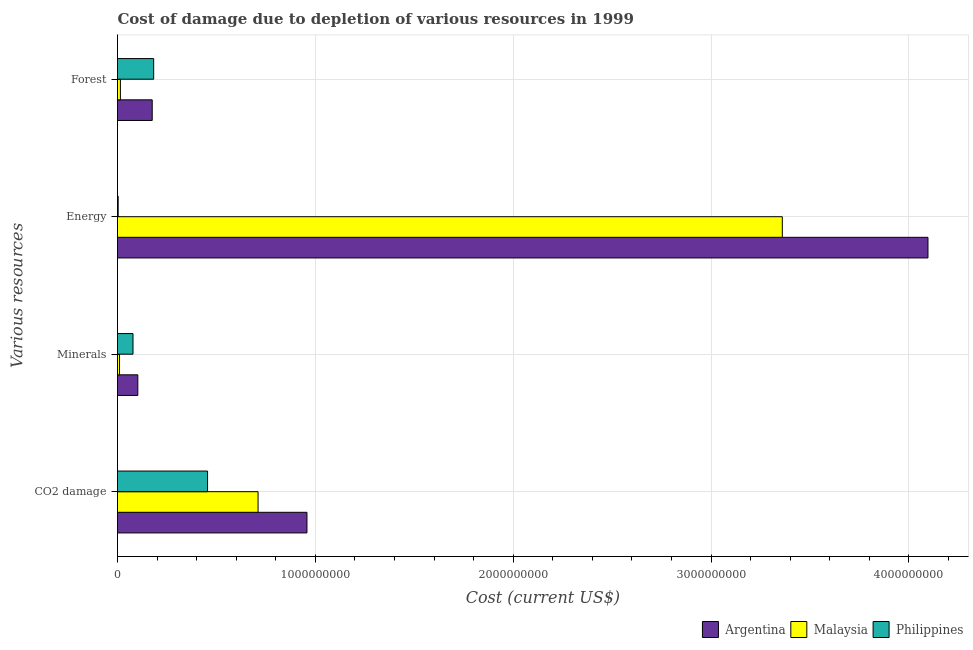How many different coloured bars are there?
Your answer should be very brief. 3. How many groups of bars are there?
Make the answer very short. 4. Are the number of bars per tick equal to the number of legend labels?
Ensure brevity in your answer.  Yes. How many bars are there on the 4th tick from the bottom?
Give a very brief answer. 3. What is the label of the 1st group of bars from the top?
Your answer should be compact. Forest. What is the cost of damage due to depletion of energy in Malaysia?
Offer a very short reply. 3.36e+09. Across all countries, what is the maximum cost of damage due to depletion of energy?
Provide a short and direct response. 4.10e+09. Across all countries, what is the minimum cost of damage due to depletion of forests?
Provide a short and direct response. 1.46e+07. In which country was the cost of damage due to depletion of coal maximum?
Offer a very short reply. Argentina. In which country was the cost of damage due to depletion of minerals minimum?
Keep it short and to the point. Malaysia. What is the total cost of damage due to depletion of coal in the graph?
Provide a succinct answer. 2.12e+09. What is the difference between the cost of damage due to depletion of forests in Malaysia and that in Philippines?
Your response must be concise. -1.68e+08. What is the difference between the cost of damage due to depletion of energy in Philippines and the cost of damage due to depletion of coal in Argentina?
Offer a very short reply. -9.54e+08. What is the average cost of damage due to depletion of energy per country?
Your answer should be very brief. 2.49e+09. What is the difference between the cost of damage due to depletion of forests and cost of damage due to depletion of energy in Philippines?
Give a very brief answer. 1.79e+08. What is the ratio of the cost of damage due to depletion of coal in Argentina to that in Philippines?
Your response must be concise. 2.1. Is the cost of damage due to depletion of coal in Philippines less than that in Argentina?
Keep it short and to the point. Yes. Is the difference between the cost of damage due to depletion of minerals in Philippines and Argentina greater than the difference between the cost of damage due to depletion of energy in Philippines and Argentina?
Provide a short and direct response. Yes. What is the difference between the highest and the second highest cost of damage due to depletion of coal?
Keep it short and to the point. 2.47e+08. What is the difference between the highest and the lowest cost of damage due to depletion of forests?
Your answer should be compact. 1.68e+08. In how many countries, is the cost of damage due to depletion of coal greater than the average cost of damage due to depletion of coal taken over all countries?
Keep it short and to the point. 2. Is it the case that in every country, the sum of the cost of damage due to depletion of forests and cost of damage due to depletion of energy is greater than the sum of cost of damage due to depletion of minerals and cost of damage due to depletion of coal?
Your answer should be very brief. No. What does the 2nd bar from the top in CO2 damage represents?
Offer a terse response. Malaysia. What does the 1st bar from the bottom in Energy represents?
Give a very brief answer. Argentina. How many bars are there?
Ensure brevity in your answer.  12. Are the values on the major ticks of X-axis written in scientific E-notation?
Provide a short and direct response. No. Does the graph contain any zero values?
Provide a short and direct response. No. Does the graph contain grids?
Your answer should be very brief. Yes. Where does the legend appear in the graph?
Ensure brevity in your answer.  Bottom right. How are the legend labels stacked?
Offer a very short reply. Horizontal. What is the title of the graph?
Give a very brief answer. Cost of damage due to depletion of various resources in 1999 . What is the label or title of the X-axis?
Your response must be concise. Cost (current US$). What is the label or title of the Y-axis?
Your response must be concise. Various resources. What is the Cost (current US$) of Argentina in CO2 damage?
Give a very brief answer. 9.58e+08. What is the Cost (current US$) of Malaysia in CO2 damage?
Make the answer very short. 7.10e+08. What is the Cost (current US$) in Philippines in CO2 damage?
Make the answer very short. 4.55e+08. What is the Cost (current US$) of Argentina in Minerals?
Ensure brevity in your answer.  1.03e+08. What is the Cost (current US$) of Malaysia in Minerals?
Give a very brief answer. 1.02e+07. What is the Cost (current US$) in Philippines in Minerals?
Offer a terse response. 7.83e+07. What is the Cost (current US$) of Argentina in Energy?
Offer a very short reply. 4.10e+09. What is the Cost (current US$) in Malaysia in Energy?
Provide a short and direct response. 3.36e+09. What is the Cost (current US$) of Philippines in Energy?
Provide a short and direct response. 3.37e+06. What is the Cost (current US$) in Argentina in Forest?
Provide a succinct answer. 1.75e+08. What is the Cost (current US$) in Malaysia in Forest?
Offer a very short reply. 1.46e+07. What is the Cost (current US$) in Philippines in Forest?
Your answer should be very brief. 1.83e+08. Across all Various resources, what is the maximum Cost (current US$) in Argentina?
Your response must be concise. 4.10e+09. Across all Various resources, what is the maximum Cost (current US$) of Malaysia?
Offer a very short reply. 3.36e+09. Across all Various resources, what is the maximum Cost (current US$) of Philippines?
Give a very brief answer. 4.55e+08. Across all Various resources, what is the minimum Cost (current US$) in Argentina?
Your answer should be compact. 1.03e+08. Across all Various resources, what is the minimum Cost (current US$) of Malaysia?
Keep it short and to the point. 1.02e+07. Across all Various resources, what is the minimum Cost (current US$) of Philippines?
Provide a succinct answer. 3.37e+06. What is the total Cost (current US$) of Argentina in the graph?
Provide a short and direct response. 5.33e+09. What is the total Cost (current US$) in Malaysia in the graph?
Keep it short and to the point. 4.10e+09. What is the total Cost (current US$) in Philippines in the graph?
Offer a terse response. 7.20e+08. What is the difference between the Cost (current US$) of Argentina in CO2 damage and that in Minerals?
Ensure brevity in your answer.  8.55e+08. What is the difference between the Cost (current US$) in Malaysia in CO2 damage and that in Minerals?
Give a very brief answer. 7.00e+08. What is the difference between the Cost (current US$) in Philippines in CO2 damage and that in Minerals?
Make the answer very short. 3.77e+08. What is the difference between the Cost (current US$) of Argentina in CO2 damage and that in Energy?
Your response must be concise. -3.14e+09. What is the difference between the Cost (current US$) of Malaysia in CO2 damage and that in Energy?
Your answer should be compact. -2.65e+09. What is the difference between the Cost (current US$) of Philippines in CO2 damage and that in Energy?
Provide a short and direct response. 4.52e+08. What is the difference between the Cost (current US$) of Argentina in CO2 damage and that in Forest?
Keep it short and to the point. 7.82e+08. What is the difference between the Cost (current US$) in Malaysia in CO2 damage and that in Forest?
Keep it short and to the point. 6.96e+08. What is the difference between the Cost (current US$) of Philippines in CO2 damage and that in Forest?
Give a very brief answer. 2.72e+08. What is the difference between the Cost (current US$) of Argentina in Minerals and that in Energy?
Keep it short and to the point. -3.99e+09. What is the difference between the Cost (current US$) in Malaysia in Minerals and that in Energy?
Your answer should be very brief. -3.35e+09. What is the difference between the Cost (current US$) in Philippines in Minerals and that in Energy?
Your response must be concise. 7.49e+07. What is the difference between the Cost (current US$) in Argentina in Minerals and that in Forest?
Make the answer very short. -7.28e+07. What is the difference between the Cost (current US$) in Malaysia in Minerals and that in Forest?
Your response must be concise. -4.38e+06. What is the difference between the Cost (current US$) of Philippines in Minerals and that in Forest?
Your answer should be very brief. -1.05e+08. What is the difference between the Cost (current US$) of Argentina in Energy and that in Forest?
Give a very brief answer. 3.92e+09. What is the difference between the Cost (current US$) of Malaysia in Energy and that in Forest?
Offer a very short reply. 3.35e+09. What is the difference between the Cost (current US$) in Philippines in Energy and that in Forest?
Your answer should be compact. -1.79e+08. What is the difference between the Cost (current US$) of Argentina in CO2 damage and the Cost (current US$) of Malaysia in Minerals?
Make the answer very short. 9.47e+08. What is the difference between the Cost (current US$) of Argentina in CO2 damage and the Cost (current US$) of Philippines in Minerals?
Your response must be concise. 8.79e+08. What is the difference between the Cost (current US$) of Malaysia in CO2 damage and the Cost (current US$) of Philippines in Minerals?
Give a very brief answer. 6.32e+08. What is the difference between the Cost (current US$) in Argentina in CO2 damage and the Cost (current US$) in Malaysia in Energy?
Your response must be concise. -2.40e+09. What is the difference between the Cost (current US$) of Argentina in CO2 damage and the Cost (current US$) of Philippines in Energy?
Make the answer very short. 9.54e+08. What is the difference between the Cost (current US$) of Malaysia in CO2 damage and the Cost (current US$) of Philippines in Energy?
Your answer should be compact. 7.07e+08. What is the difference between the Cost (current US$) of Argentina in CO2 damage and the Cost (current US$) of Malaysia in Forest?
Offer a very short reply. 9.43e+08. What is the difference between the Cost (current US$) in Argentina in CO2 damage and the Cost (current US$) in Philippines in Forest?
Your answer should be very brief. 7.75e+08. What is the difference between the Cost (current US$) of Malaysia in CO2 damage and the Cost (current US$) of Philippines in Forest?
Offer a terse response. 5.28e+08. What is the difference between the Cost (current US$) of Argentina in Minerals and the Cost (current US$) of Malaysia in Energy?
Provide a short and direct response. -3.26e+09. What is the difference between the Cost (current US$) of Argentina in Minerals and the Cost (current US$) of Philippines in Energy?
Provide a short and direct response. 9.93e+07. What is the difference between the Cost (current US$) of Malaysia in Minerals and the Cost (current US$) of Philippines in Energy?
Offer a very short reply. 6.88e+06. What is the difference between the Cost (current US$) in Argentina in Minerals and the Cost (current US$) in Malaysia in Forest?
Give a very brief answer. 8.80e+07. What is the difference between the Cost (current US$) in Argentina in Minerals and the Cost (current US$) in Philippines in Forest?
Offer a very short reply. -8.02e+07. What is the difference between the Cost (current US$) of Malaysia in Minerals and the Cost (current US$) of Philippines in Forest?
Ensure brevity in your answer.  -1.73e+08. What is the difference between the Cost (current US$) of Argentina in Energy and the Cost (current US$) of Malaysia in Forest?
Make the answer very short. 4.08e+09. What is the difference between the Cost (current US$) in Argentina in Energy and the Cost (current US$) in Philippines in Forest?
Give a very brief answer. 3.91e+09. What is the difference between the Cost (current US$) of Malaysia in Energy and the Cost (current US$) of Philippines in Forest?
Offer a terse response. 3.18e+09. What is the average Cost (current US$) of Argentina per Various resources?
Provide a succinct answer. 1.33e+09. What is the average Cost (current US$) in Malaysia per Various resources?
Your answer should be compact. 1.02e+09. What is the average Cost (current US$) of Philippines per Various resources?
Keep it short and to the point. 1.80e+08. What is the difference between the Cost (current US$) in Argentina and Cost (current US$) in Malaysia in CO2 damage?
Provide a succinct answer. 2.47e+08. What is the difference between the Cost (current US$) of Argentina and Cost (current US$) of Philippines in CO2 damage?
Keep it short and to the point. 5.02e+08. What is the difference between the Cost (current US$) of Malaysia and Cost (current US$) of Philippines in CO2 damage?
Give a very brief answer. 2.55e+08. What is the difference between the Cost (current US$) in Argentina and Cost (current US$) in Malaysia in Minerals?
Provide a succinct answer. 9.24e+07. What is the difference between the Cost (current US$) of Argentina and Cost (current US$) of Philippines in Minerals?
Offer a very short reply. 2.43e+07. What is the difference between the Cost (current US$) of Malaysia and Cost (current US$) of Philippines in Minerals?
Offer a very short reply. -6.80e+07. What is the difference between the Cost (current US$) in Argentina and Cost (current US$) in Malaysia in Energy?
Offer a terse response. 7.36e+08. What is the difference between the Cost (current US$) of Argentina and Cost (current US$) of Philippines in Energy?
Your answer should be compact. 4.09e+09. What is the difference between the Cost (current US$) in Malaysia and Cost (current US$) in Philippines in Energy?
Your response must be concise. 3.36e+09. What is the difference between the Cost (current US$) in Argentina and Cost (current US$) in Malaysia in Forest?
Your response must be concise. 1.61e+08. What is the difference between the Cost (current US$) of Argentina and Cost (current US$) of Philippines in Forest?
Offer a very short reply. -7.34e+06. What is the difference between the Cost (current US$) in Malaysia and Cost (current US$) in Philippines in Forest?
Make the answer very short. -1.68e+08. What is the ratio of the Cost (current US$) of Argentina in CO2 damage to that in Minerals?
Keep it short and to the point. 9.33. What is the ratio of the Cost (current US$) in Malaysia in CO2 damage to that in Minerals?
Your answer should be very brief. 69.32. What is the ratio of the Cost (current US$) in Philippines in CO2 damage to that in Minerals?
Your answer should be compact. 5.81. What is the ratio of the Cost (current US$) of Argentina in CO2 damage to that in Energy?
Give a very brief answer. 0.23. What is the ratio of the Cost (current US$) of Malaysia in CO2 damage to that in Energy?
Your response must be concise. 0.21. What is the ratio of the Cost (current US$) in Philippines in CO2 damage to that in Energy?
Offer a very short reply. 135.15. What is the ratio of the Cost (current US$) in Argentina in CO2 damage to that in Forest?
Make the answer very short. 5.46. What is the ratio of the Cost (current US$) of Malaysia in CO2 damage to that in Forest?
Your answer should be compact. 48.57. What is the ratio of the Cost (current US$) of Philippines in CO2 damage to that in Forest?
Keep it short and to the point. 2.49. What is the ratio of the Cost (current US$) of Argentina in Minerals to that in Energy?
Offer a terse response. 0.03. What is the ratio of the Cost (current US$) in Malaysia in Minerals to that in Energy?
Your response must be concise. 0. What is the ratio of the Cost (current US$) in Philippines in Minerals to that in Energy?
Provide a short and direct response. 23.24. What is the ratio of the Cost (current US$) in Argentina in Minerals to that in Forest?
Ensure brevity in your answer.  0.58. What is the ratio of the Cost (current US$) in Malaysia in Minerals to that in Forest?
Offer a terse response. 0.7. What is the ratio of the Cost (current US$) of Philippines in Minerals to that in Forest?
Give a very brief answer. 0.43. What is the ratio of the Cost (current US$) in Argentina in Energy to that in Forest?
Your answer should be compact. 23.35. What is the ratio of the Cost (current US$) of Malaysia in Energy to that in Forest?
Give a very brief answer. 229.73. What is the ratio of the Cost (current US$) of Philippines in Energy to that in Forest?
Provide a succinct answer. 0.02. What is the difference between the highest and the second highest Cost (current US$) in Argentina?
Your answer should be compact. 3.14e+09. What is the difference between the highest and the second highest Cost (current US$) in Malaysia?
Ensure brevity in your answer.  2.65e+09. What is the difference between the highest and the second highest Cost (current US$) in Philippines?
Make the answer very short. 2.72e+08. What is the difference between the highest and the lowest Cost (current US$) of Argentina?
Your answer should be very brief. 3.99e+09. What is the difference between the highest and the lowest Cost (current US$) in Malaysia?
Keep it short and to the point. 3.35e+09. What is the difference between the highest and the lowest Cost (current US$) of Philippines?
Offer a very short reply. 4.52e+08. 